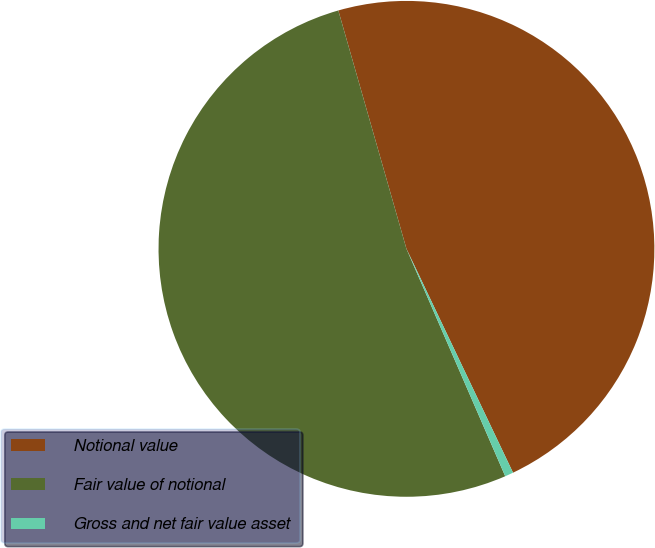Convert chart. <chart><loc_0><loc_0><loc_500><loc_500><pie_chart><fcel>Notional value<fcel>Fair value of notional<fcel>Gross and net fair value asset<nl><fcel>47.36%<fcel>52.09%<fcel>0.55%<nl></chart> 